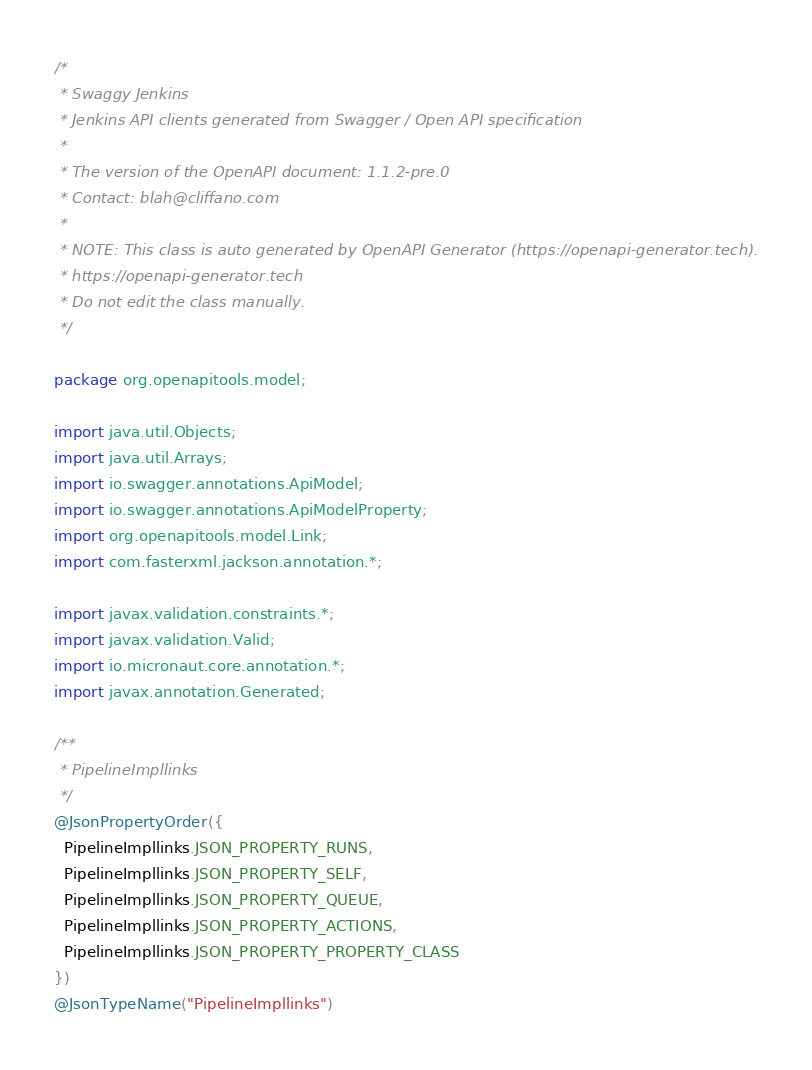Convert code to text. <code><loc_0><loc_0><loc_500><loc_500><_Java_>/*
 * Swaggy Jenkins
 * Jenkins API clients generated from Swagger / Open API specification
 *
 * The version of the OpenAPI document: 1.1.2-pre.0
 * Contact: blah@cliffano.com
 *
 * NOTE: This class is auto generated by OpenAPI Generator (https://openapi-generator.tech).
 * https://openapi-generator.tech
 * Do not edit the class manually.
 */

package org.openapitools.model;

import java.util.Objects;
import java.util.Arrays;
import io.swagger.annotations.ApiModel;
import io.swagger.annotations.ApiModelProperty;
import org.openapitools.model.Link;
import com.fasterxml.jackson.annotation.*;

import javax.validation.constraints.*;
import javax.validation.Valid;
import io.micronaut.core.annotation.*;
import javax.annotation.Generated;

/**
 * PipelineImpllinks
 */
@JsonPropertyOrder({
  PipelineImpllinks.JSON_PROPERTY_RUNS,
  PipelineImpllinks.JSON_PROPERTY_SELF,
  PipelineImpllinks.JSON_PROPERTY_QUEUE,
  PipelineImpllinks.JSON_PROPERTY_ACTIONS,
  PipelineImpllinks.JSON_PROPERTY_PROPERTY_CLASS
})
@JsonTypeName("PipelineImpllinks")</code> 